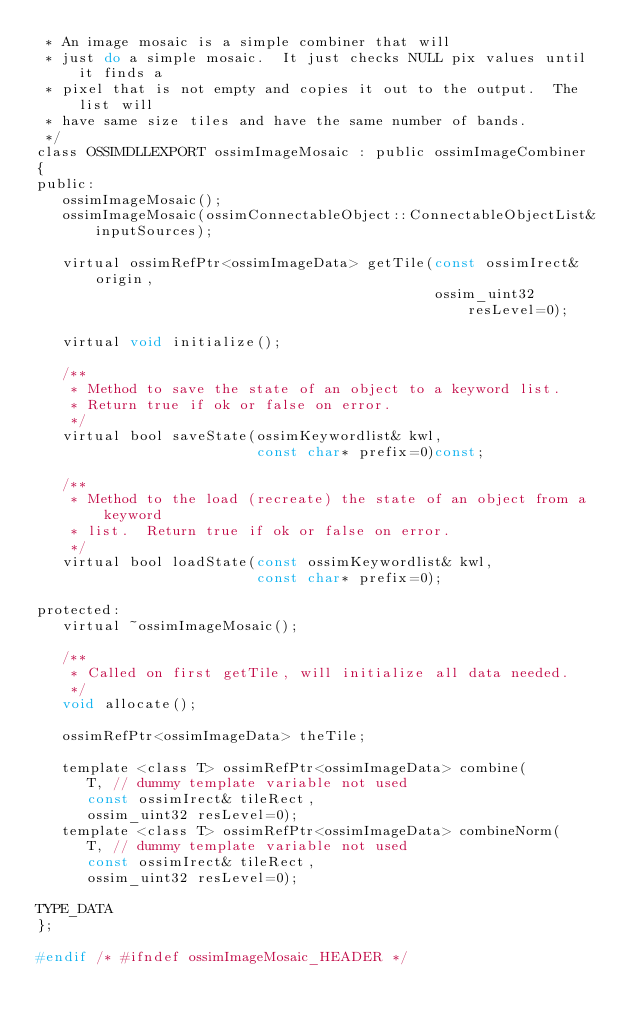Convert code to text. <code><loc_0><loc_0><loc_500><loc_500><_C_> * An image mosaic is a simple combiner that will
 * just do a simple mosaic.  It just checks NULL pix values until it finds a
 * pixel that is not empty and copies it out to the output.  The list will
 * have same size tiles and have the same number of bands.
 */
class OSSIMDLLEXPORT ossimImageMosaic : public ossimImageCombiner
{
public:
   ossimImageMosaic();
   ossimImageMosaic(ossimConnectableObject::ConnectableObjectList& inputSources);
   
   virtual ossimRefPtr<ossimImageData> getTile(const ossimIrect& origin,
                                               ossim_uint32 resLevel=0);
   
   virtual void initialize();
   
   /**
    * Method to save the state of an object to a keyword list.
    * Return true if ok or false on error.
    */
   virtual bool saveState(ossimKeywordlist& kwl,
                          const char* prefix=0)const;

   /**
    * Method to the load (recreate) the state of an object from a keyword
    * list.  Return true if ok or false on error.
    */
   virtual bool loadState(const ossimKeywordlist& kwl,
                          const char* prefix=0);

protected:
   virtual ~ossimImageMosaic();

   /**
    * Called on first getTile, will initialize all data needed.
    */
   void allocate();
   
   ossimRefPtr<ossimImageData> theTile;

   template <class T> ossimRefPtr<ossimImageData> combine(
      T, // dummy template variable not used
      const ossimIrect& tileRect,
      ossim_uint32 resLevel=0);
   template <class T> ossimRefPtr<ossimImageData> combineNorm(
      T, // dummy template variable not used
      const ossimIrect& tileRect,
      ossim_uint32 resLevel=0);

TYPE_DATA
};

#endif /* #ifndef ossimImageMosaic_HEADER */
</code> 